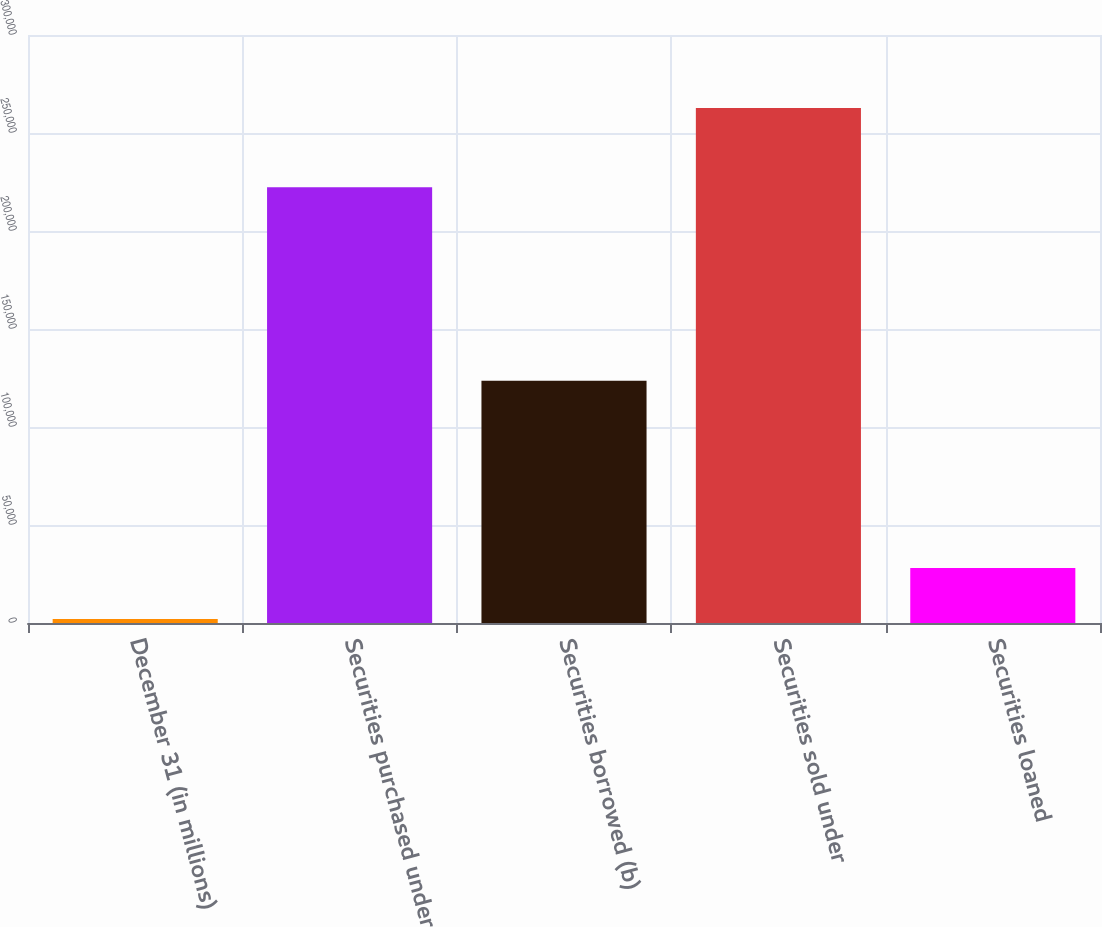Convert chart to OTSL. <chart><loc_0><loc_0><loc_500><loc_500><bar_chart><fcel>December 31 (in millions)<fcel>Securities purchased under<fcel>Securities borrowed (b)<fcel>Securities sold under<fcel>Securities loaned<nl><fcel>2010<fcel>222302<fcel>123587<fcel>262722<fcel>28081.2<nl></chart> 